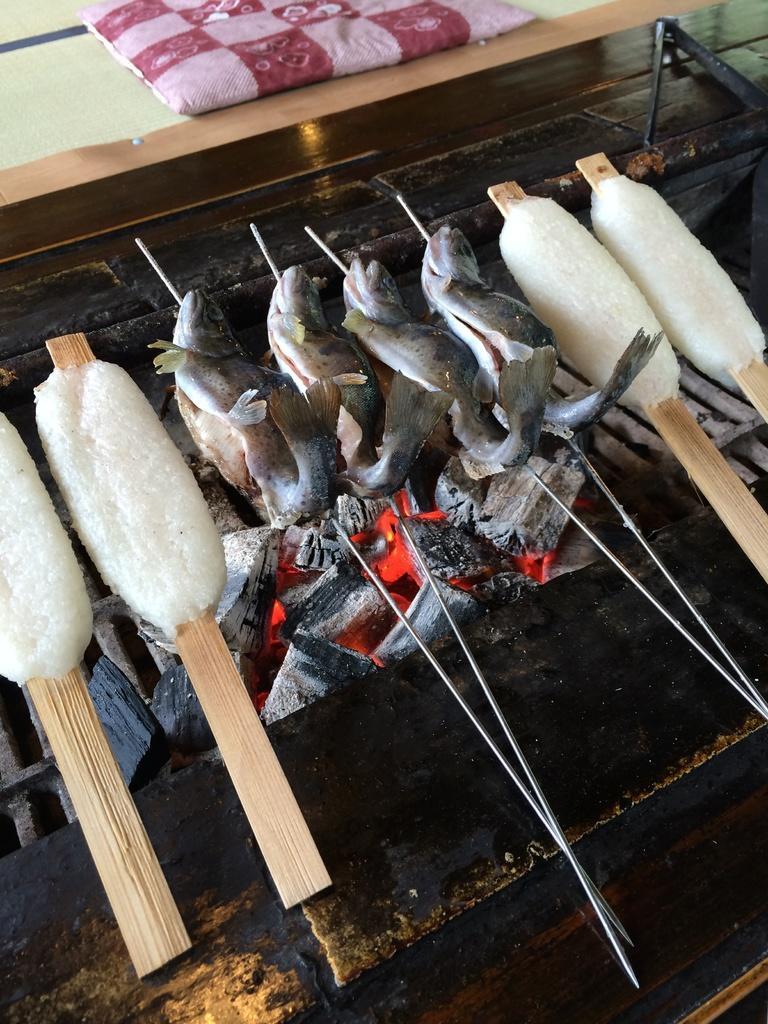Can you describe this image briefly? In the center of the image we can see fish and ice placed on the grill. 